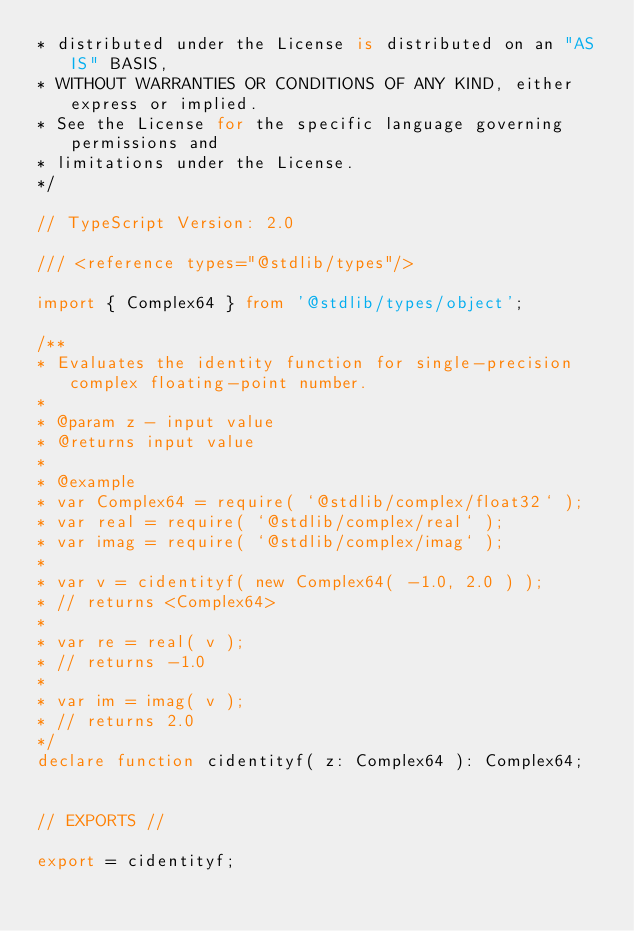<code> <loc_0><loc_0><loc_500><loc_500><_TypeScript_>* distributed under the License is distributed on an "AS IS" BASIS,
* WITHOUT WARRANTIES OR CONDITIONS OF ANY KIND, either express or implied.
* See the License for the specific language governing permissions and
* limitations under the License.
*/

// TypeScript Version: 2.0

/// <reference types="@stdlib/types"/>

import { Complex64 } from '@stdlib/types/object';

/**
* Evaluates the identity function for single-precision complex floating-point number.
*
* @param z - input value
* @returns input value
*
* @example
* var Complex64 = require( `@stdlib/complex/float32` );
* var real = require( `@stdlib/complex/real` );
* var imag = require( `@stdlib/complex/imag` );
*
* var v = cidentityf( new Complex64( -1.0, 2.0 ) );
* // returns <Complex64>
*
* var re = real( v );
* // returns -1.0
*
* var im = imag( v );
* // returns 2.0
*/
declare function cidentityf( z: Complex64 ): Complex64;


// EXPORTS //

export = cidentityf;
</code> 